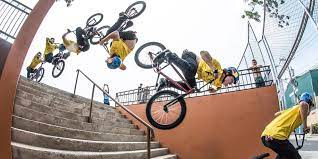What kind of equipment do you think is essential for such BMX stunts? Performing BMX stunts typically requires a sturdy BMX bike designed for tricks, with features like pegs for grinds, a lightweight frame for aerial maneuvers, and robust wheels. Safety gear is also crucial, including a helmet, knee and elbow pads, and gloves. 